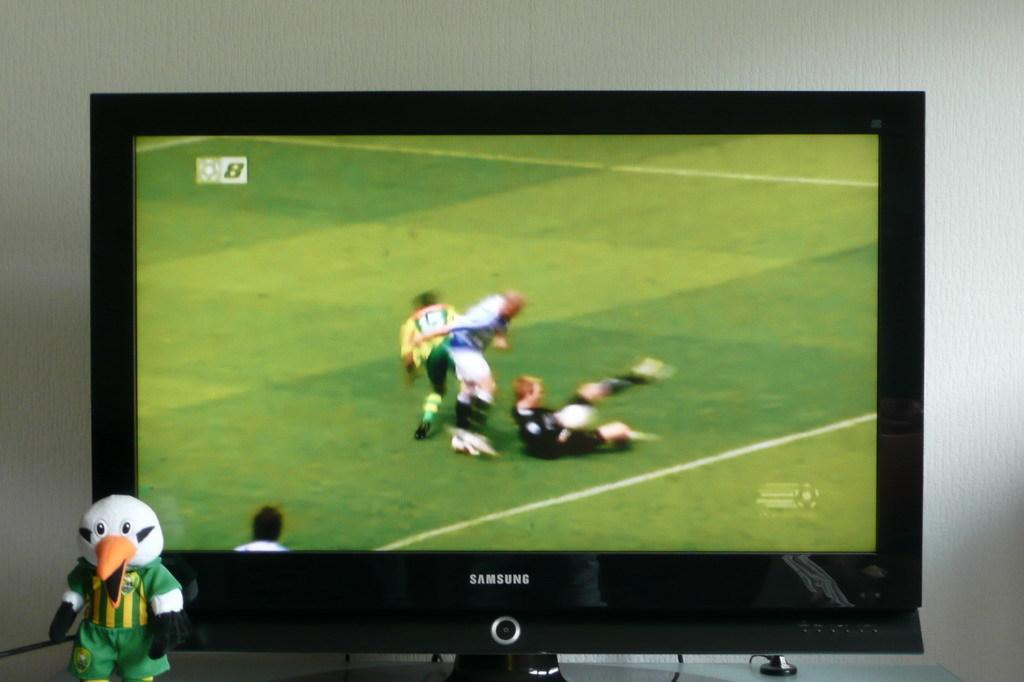<image>
Summarize the visual content of the image. a Samsung television that has some soccer players on it 